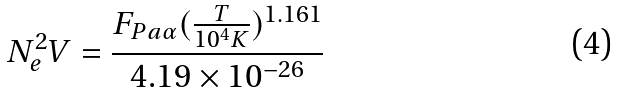Convert formula to latex. <formula><loc_0><loc_0><loc_500><loc_500>N _ { e } ^ { 2 } V = \frac { F _ { P a \alpha } ( \frac { T } { 1 0 ^ { 4 } K } ) ^ { 1 . 1 6 1 } } { 4 . 1 9 \times 1 0 ^ { - 2 6 } }</formula> 